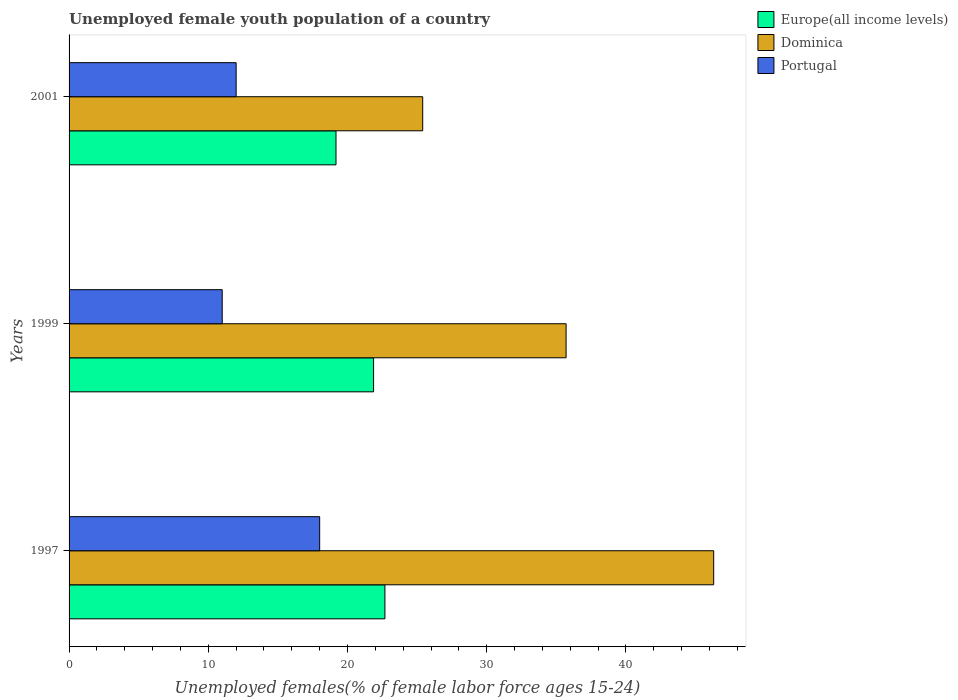How many different coloured bars are there?
Provide a short and direct response. 3. How many groups of bars are there?
Provide a short and direct response. 3. How many bars are there on the 3rd tick from the top?
Your answer should be compact. 3. What is the label of the 1st group of bars from the top?
Offer a terse response. 2001. In how many cases, is the number of bars for a given year not equal to the number of legend labels?
Your response must be concise. 0. What is the percentage of unemployed female youth population in Europe(all income levels) in 2001?
Your answer should be very brief. 19.17. Across all years, what is the maximum percentage of unemployed female youth population in Portugal?
Make the answer very short. 18. Across all years, what is the minimum percentage of unemployed female youth population in Europe(all income levels)?
Offer a terse response. 19.17. In which year was the percentage of unemployed female youth population in Dominica maximum?
Offer a terse response. 1997. In which year was the percentage of unemployed female youth population in Europe(all income levels) minimum?
Keep it short and to the point. 2001. What is the total percentage of unemployed female youth population in Dominica in the graph?
Your answer should be very brief. 107.4. What is the difference between the percentage of unemployed female youth population in Portugal in 1997 and the percentage of unemployed female youth population in Dominica in 2001?
Ensure brevity in your answer.  -7.4. What is the average percentage of unemployed female youth population in Portugal per year?
Your response must be concise. 13.67. In the year 1999, what is the difference between the percentage of unemployed female youth population in Dominica and percentage of unemployed female youth population in Europe(all income levels)?
Keep it short and to the point. 13.83. In how many years, is the percentage of unemployed female youth population in Europe(all income levels) greater than 8 %?
Ensure brevity in your answer.  3. What is the ratio of the percentage of unemployed female youth population in Europe(all income levels) in 1999 to that in 2001?
Your response must be concise. 1.14. What is the difference between the highest and the second highest percentage of unemployed female youth population in Europe(all income levels)?
Offer a terse response. 0.81. What is the difference between the highest and the lowest percentage of unemployed female youth population in Dominica?
Your response must be concise. 20.9. In how many years, is the percentage of unemployed female youth population in Portugal greater than the average percentage of unemployed female youth population in Portugal taken over all years?
Give a very brief answer. 1. Is the sum of the percentage of unemployed female youth population in Europe(all income levels) in 1999 and 2001 greater than the maximum percentage of unemployed female youth population in Dominica across all years?
Your response must be concise. No. What does the 1st bar from the top in 1997 represents?
Make the answer very short. Portugal. What does the 2nd bar from the bottom in 1999 represents?
Your answer should be very brief. Dominica. Is it the case that in every year, the sum of the percentage of unemployed female youth population in Europe(all income levels) and percentage of unemployed female youth population in Dominica is greater than the percentage of unemployed female youth population in Portugal?
Give a very brief answer. Yes. How many years are there in the graph?
Ensure brevity in your answer.  3. What is the difference between two consecutive major ticks on the X-axis?
Your answer should be very brief. 10. Does the graph contain grids?
Make the answer very short. No. Where does the legend appear in the graph?
Make the answer very short. Top right. How many legend labels are there?
Your answer should be very brief. 3. How are the legend labels stacked?
Make the answer very short. Vertical. What is the title of the graph?
Keep it short and to the point. Unemployed female youth population of a country. Does "Paraguay" appear as one of the legend labels in the graph?
Ensure brevity in your answer.  No. What is the label or title of the X-axis?
Provide a short and direct response. Unemployed females(% of female labor force ages 15-24). What is the Unemployed females(% of female labor force ages 15-24) of Europe(all income levels) in 1997?
Your answer should be compact. 22.69. What is the Unemployed females(% of female labor force ages 15-24) of Dominica in 1997?
Your answer should be very brief. 46.3. What is the Unemployed females(% of female labor force ages 15-24) of Europe(all income levels) in 1999?
Give a very brief answer. 21.87. What is the Unemployed females(% of female labor force ages 15-24) in Dominica in 1999?
Keep it short and to the point. 35.7. What is the Unemployed females(% of female labor force ages 15-24) of Europe(all income levels) in 2001?
Your answer should be compact. 19.17. What is the Unemployed females(% of female labor force ages 15-24) of Dominica in 2001?
Your answer should be compact. 25.4. Across all years, what is the maximum Unemployed females(% of female labor force ages 15-24) of Europe(all income levels)?
Make the answer very short. 22.69. Across all years, what is the maximum Unemployed females(% of female labor force ages 15-24) in Dominica?
Ensure brevity in your answer.  46.3. Across all years, what is the minimum Unemployed females(% of female labor force ages 15-24) of Europe(all income levels)?
Make the answer very short. 19.17. Across all years, what is the minimum Unemployed females(% of female labor force ages 15-24) of Dominica?
Offer a very short reply. 25.4. Across all years, what is the minimum Unemployed females(% of female labor force ages 15-24) in Portugal?
Provide a succinct answer. 11. What is the total Unemployed females(% of female labor force ages 15-24) in Europe(all income levels) in the graph?
Provide a succinct answer. 63.73. What is the total Unemployed females(% of female labor force ages 15-24) in Dominica in the graph?
Your answer should be compact. 107.4. What is the difference between the Unemployed females(% of female labor force ages 15-24) in Europe(all income levels) in 1997 and that in 1999?
Ensure brevity in your answer.  0.81. What is the difference between the Unemployed females(% of female labor force ages 15-24) of Dominica in 1997 and that in 1999?
Ensure brevity in your answer.  10.6. What is the difference between the Unemployed females(% of female labor force ages 15-24) in Europe(all income levels) in 1997 and that in 2001?
Keep it short and to the point. 3.51. What is the difference between the Unemployed females(% of female labor force ages 15-24) of Dominica in 1997 and that in 2001?
Ensure brevity in your answer.  20.9. What is the difference between the Unemployed females(% of female labor force ages 15-24) in Portugal in 1997 and that in 2001?
Keep it short and to the point. 6. What is the difference between the Unemployed females(% of female labor force ages 15-24) in Europe(all income levels) in 1999 and that in 2001?
Provide a succinct answer. 2.7. What is the difference between the Unemployed females(% of female labor force ages 15-24) of Dominica in 1999 and that in 2001?
Provide a short and direct response. 10.3. What is the difference between the Unemployed females(% of female labor force ages 15-24) of Portugal in 1999 and that in 2001?
Provide a succinct answer. -1. What is the difference between the Unemployed females(% of female labor force ages 15-24) of Europe(all income levels) in 1997 and the Unemployed females(% of female labor force ages 15-24) of Dominica in 1999?
Make the answer very short. -13.01. What is the difference between the Unemployed females(% of female labor force ages 15-24) in Europe(all income levels) in 1997 and the Unemployed females(% of female labor force ages 15-24) in Portugal in 1999?
Ensure brevity in your answer.  11.69. What is the difference between the Unemployed females(% of female labor force ages 15-24) of Dominica in 1997 and the Unemployed females(% of female labor force ages 15-24) of Portugal in 1999?
Your response must be concise. 35.3. What is the difference between the Unemployed females(% of female labor force ages 15-24) of Europe(all income levels) in 1997 and the Unemployed females(% of female labor force ages 15-24) of Dominica in 2001?
Offer a very short reply. -2.71. What is the difference between the Unemployed females(% of female labor force ages 15-24) in Europe(all income levels) in 1997 and the Unemployed females(% of female labor force ages 15-24) in Portugal in 2001?
Your answer should be very brief. 10.69. What is the difference between the Unemployed females(% of female labor force ages 15-24) in Dominica in 1997 and the Unemployed females(% of female labor force ages 15-24) in Portugal in 2001?
Your answer should be very brief. 34.3. What is the difference between the Unemployed females(% of female labor force ages 15-24) in Europe(all income levels) in 1999 and the Unemployed females(% of female labor force ages 15-24) in Dominica in 2001?
Offer a terse response. -3.53. What is the difference between the Unemployed females(% of female labor force ages 15-24) of Europe(all income levels) in 1999 and the Unemployed females(% of female labor force ages 15-24) of Portugal in 2001?
Your answer should be very brief. 9.87. What is the difference between the Unemployed females(% of female labor force ages 15-24) in Dominica in 1999 and the Unemployed females(% of female labor force ages 15-24) in Portugal in 2001?
Ensure brevity in your answer.  23.7. What is the average Unemployed females(% of female labor force ages 15-24) of Europe(all income levels) per year?
Provide a short and direct response. 21.24. What is the average Unemployed females(% of female labor force ages 15-24) of Dominica per year?
Offer a very short reply. 35.8. What is the average Unemployed females(% of female labor force ages 15-24) in Portugal per year?
Offer a very short reply. 13.67. In the year 1997, what is the difference between the Unemployed females(% of female labor force ages 15-24) in Europe(all income levels) and Unemployed females(% of female labor force ages 15-24) in Dominica?
Your answer should be compact. -23.61. In the year 1997, what is the difference between the Unemployed females(% of female labor force ages 15-24) in Europe(all income levels) and Unemployed females(% of female labor force ages 15-24) in Portugal?
Provide a short and direct response. 4.69. In the year 1997, what is the difference between the Unemployed females(% of female labor force ages 15-24) of Dominica and Unemployed females(% of female labor force ages 15-24) of Portugal?
Give a very brief answer. 28.3. In the year 1999, what is the difference between the Unemployed females(% of female labor force ages 15-24) in Europe(all income levels) and Unemployed females(% of female labor force ages 15-24) in Dominica?
Provide a short and direct response. -13.83. In the year 1999, what is the difference between the Unemployed females(% of female labor force ages 15-24) in Europe(all income levels) and Unemployed females(% of female labor force ages 15-24) in Portugal?
Your answer should be very brief. 10.87. In the year 1999, what is the difference between the Unemployed females(% of female labor force ages 15-24) in Dominica and Unemployed females(% of female labor force ages 15-24) in Portugal?
Provide a short and direct response. 24.7. In the year 2001, what is the difference between the Unemployed females(% of female labor force ages 15-24) of Europe(all income levels) and Unemployed females(% of female labor force ages 15-24) of Dominica?
Make the answer very short. -6.23. In the year 2001, what is the difference between the Unemployed females(% of female labor force ages 15-24) of Europe(all income levels) and Unemployed females(% of female labor force ages 15-24) of Portugal?
Give a very brief answer. 7.17. In the year 2001, what is the difference between the Unemployed females(% of female labor force ages 15-24) in Dominica and Unemployed females(% of female labor force ages 15-24) in Portugal?
Provide a short and direct response. 13.4. What is the ratio of the Unemployed females(% of female labor force ages 15-24) of Europe(all income levels) in 1997 to that in 1999?
Ensure brevity in your answer.  1.04. What is the ratio of the Unemployed females(% of female labor force ages 15-24) in Dominica in 1997 to that in 1999?
Keep it short and to the point. 1.3. What is the ratio of the Unemployed females(% of female labor force ages 15-24) of Portugal in 1997 to that in 1999?
Make the answer very short. 1.64. What is the ratio of the Unemployed females(% of female labor force ages 15-24) in Europe(all income levels) in 1997 to that in 2001?
Your answer should be compact. 1.18. What is the ratio of the Unemployed females(% of female labor force ages 15-24) in Dominica in 1997 to that in 2001?
Your response must be concise. 1.82. What is the ratio of the Unemployed females(% of female labor force ages 15-24) in Portugal in 1997 to that in 2001?
Make the answer very short. 1.5. What is the ratio of the Unemployed females(% of female labor force ages 15-24) of Europe(all income levels) in 1999 to that in 2001?
Provide a succinct answer. 1.14. What is the ratio of the Unemployed females(% of female labor force ages 15-24) in Dominica in 1999 to that in 2001?
Keep it short and to the point. 1.41. What is the difference between the highest and the second highest Unemployed females(% of female labor force ages 15-24) in Europe(all income levels)?
Provide a succinct answer. 0.81. What is the difference between the highest and the second highest Unemployed females(% of female labor force ages 15-24) of Portugal?
Keep it short and to the point. 6. What is the difference between the highest and the lowest Unemployed females(% of female labor force ages 15-24) of Europe(all income levels)?
Your answer should be very brief. 3.51. What is the difference between the highest and the lowest Unemployed females(% of female labor force ages 15-24) of Dominica?
Keep it short and to the point. 20.9. 